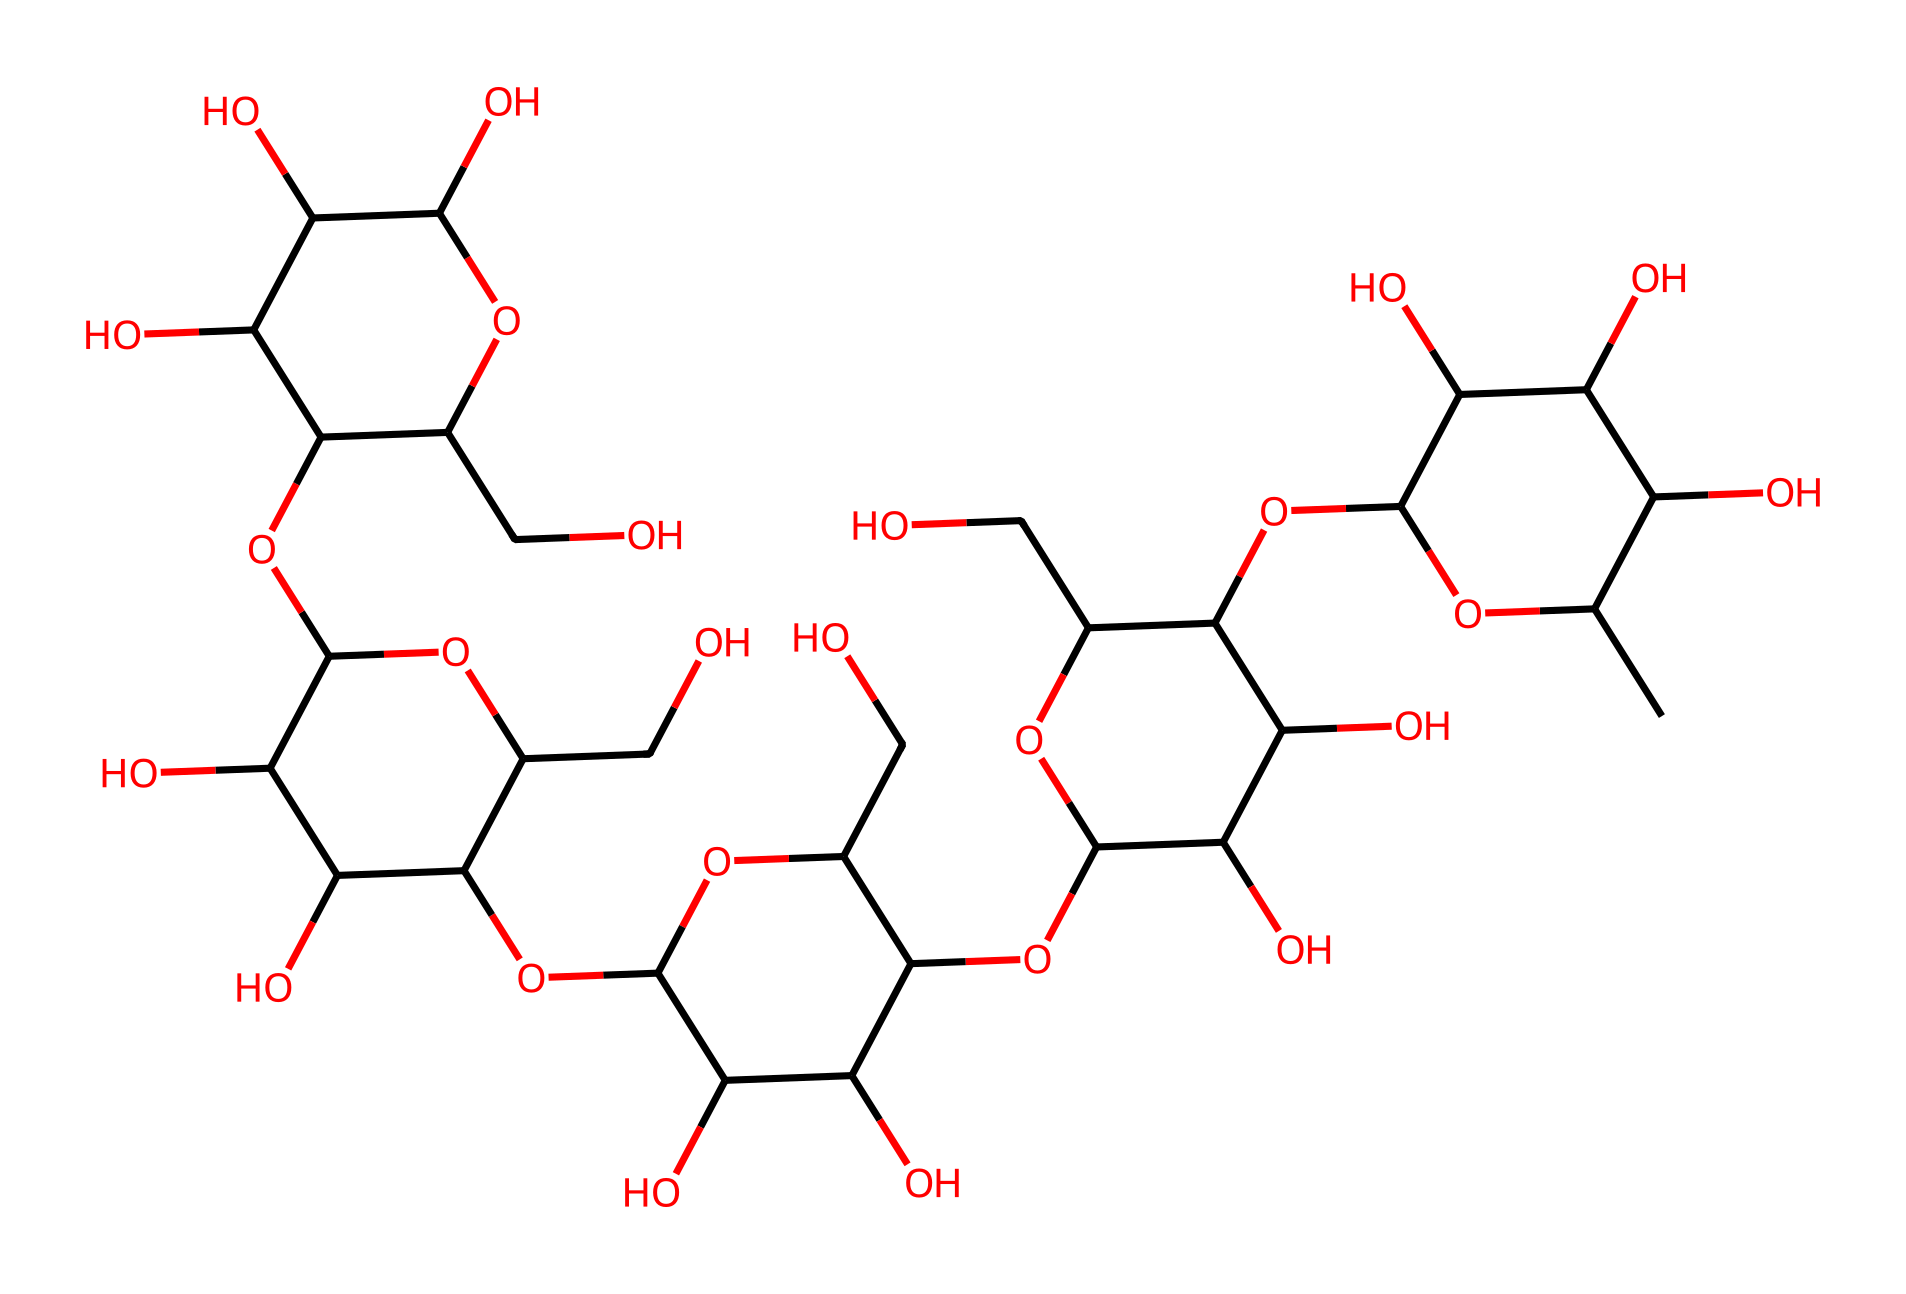What is the molecular formula of xanthan gum? To determine the molecular formula, we count the number of carbon, hydrogen, and oxygen atoms in the SMILES representation. By analyzing the structure, we find there are 35 carbons, 49 hydrogens, and 15 oxygens. Therefore, the molecular formula is C35H49O15.
Answer: C35H49O15 How many rings are present in the xanthan gum structure? By examining the SMILES representation, we identify the parts where numbers indicate ring formations. The presence of numbers like 1, 2, ... indicates that there are cyclic structures. Counting these gives us a total of 5 rings in the xanthan gum structure.
Answer: 5 What type of glycosidic linkages are present in xanthan gum? The structure of xanthan gum shows multiple sugar units linked by glycosidic bonds. In this structure, we observe primarily beta-glycosidic linkages due to the orientation of substituent hydroxyl (OH) groups. This is typical in polysaccharides derived from bacterial fermentation.
Answer: beta-glycosidic What non-Newtonian behavior does xanthan gum primarily exhibit? Xanthan gum is known for its shear-thinning behavior, meaning that its viscosity decreases under shear stress. This characteristic is crucial for applications in food products where it provides stability and smooth texture, allowing for easier processing.
Answer: shear-thinning What is the primary application of xanthan gum in food products? Xanthan gum is primarily used as a thickening agent and stabilizer in food products. Its ability to create desirable textures and prevent separation makes it a popular additive in dressings, sauces, and desserts.
Answer: thickening agent 